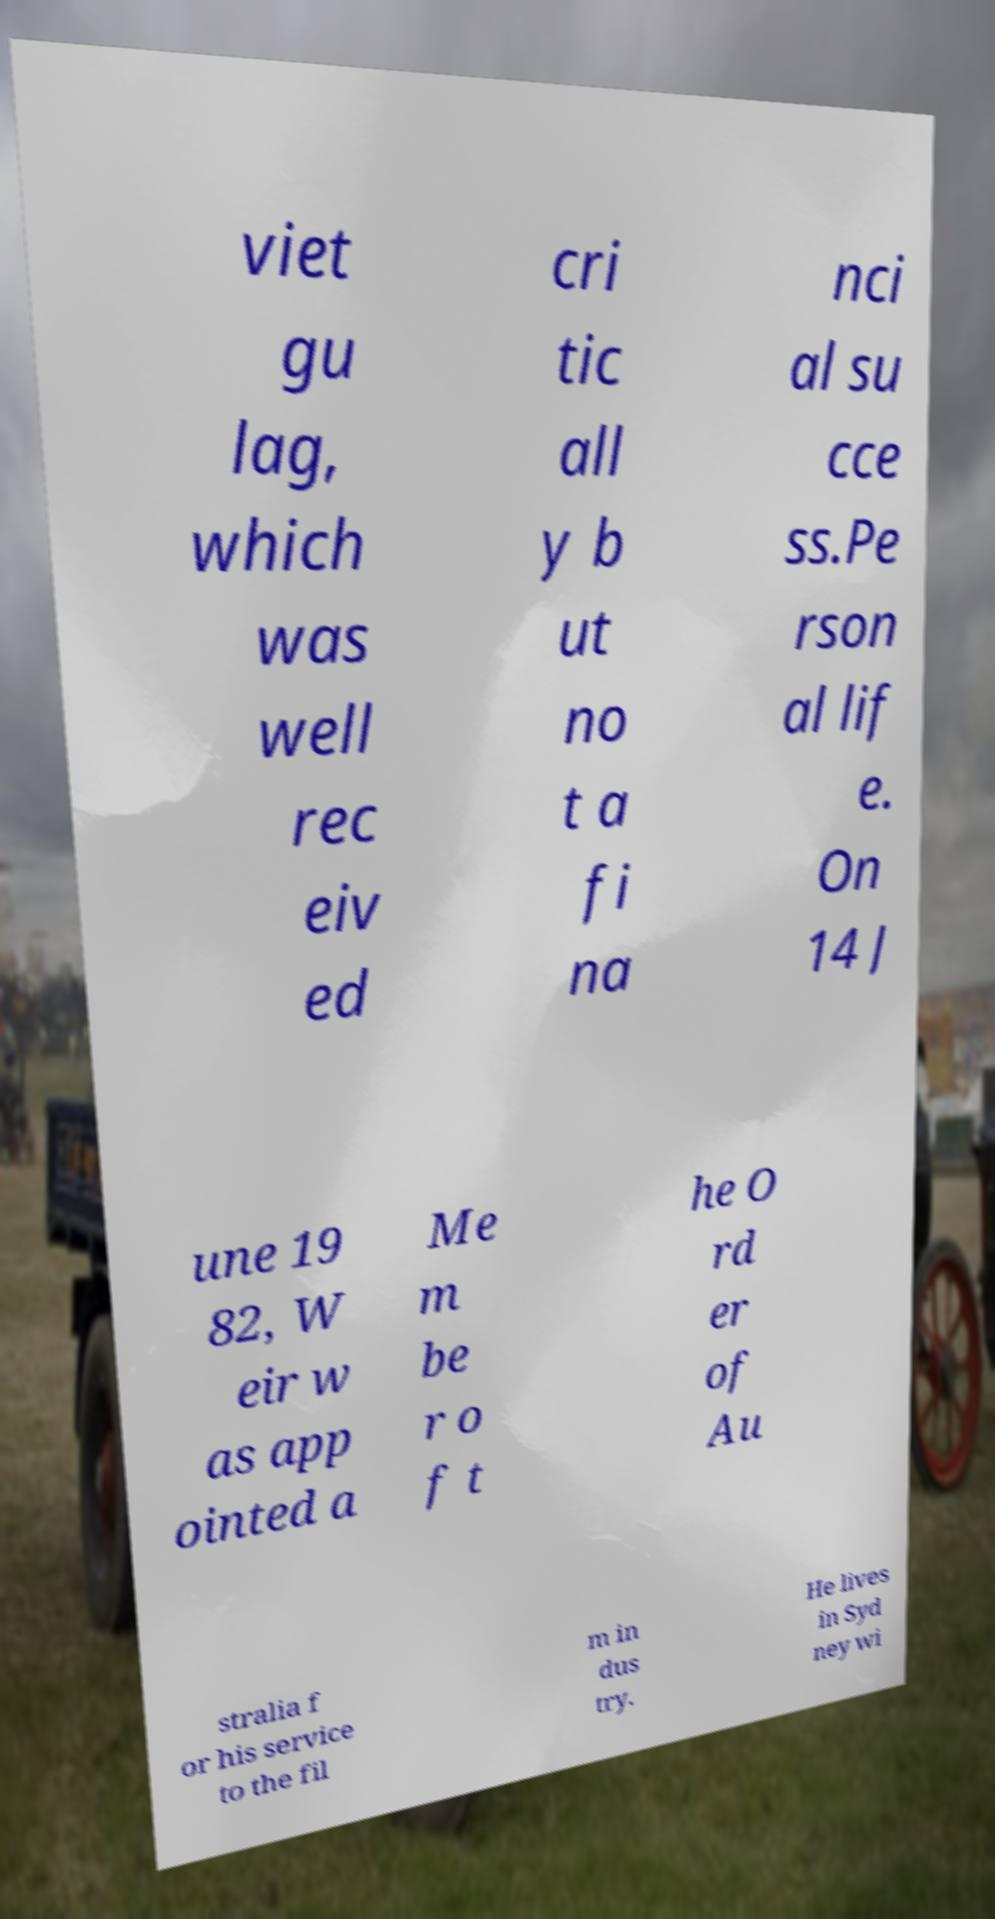I need the written content from this picture converted into text. Can you do that? viet gu lag, which was well rec eiv ed cri tic all y b ut no t a fi na nci al su cce ss.Pe rson al lif e. On 14 J une 19 82, W eir w as app ointed a Me m be r o f t he O rd er of Au stralia f or his service to the fil m in dus try. He lives in Syd ney wi 